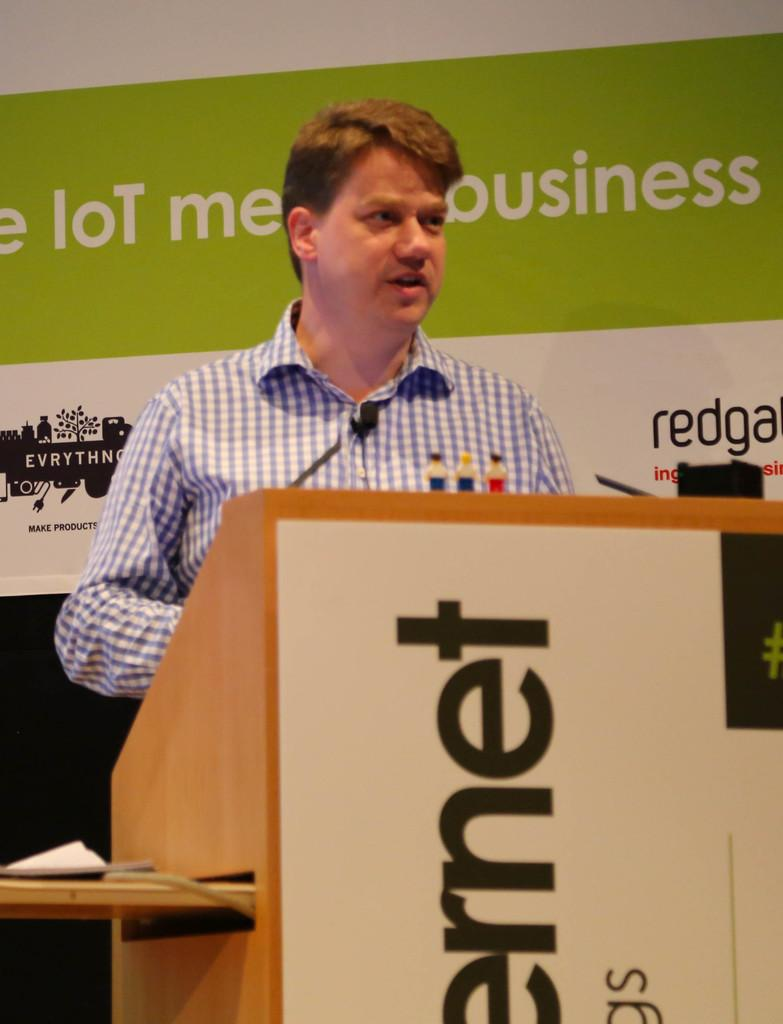Provide a one-sentence caption for the provided image. Man giving a speech in front of a podium that says "rnet". 